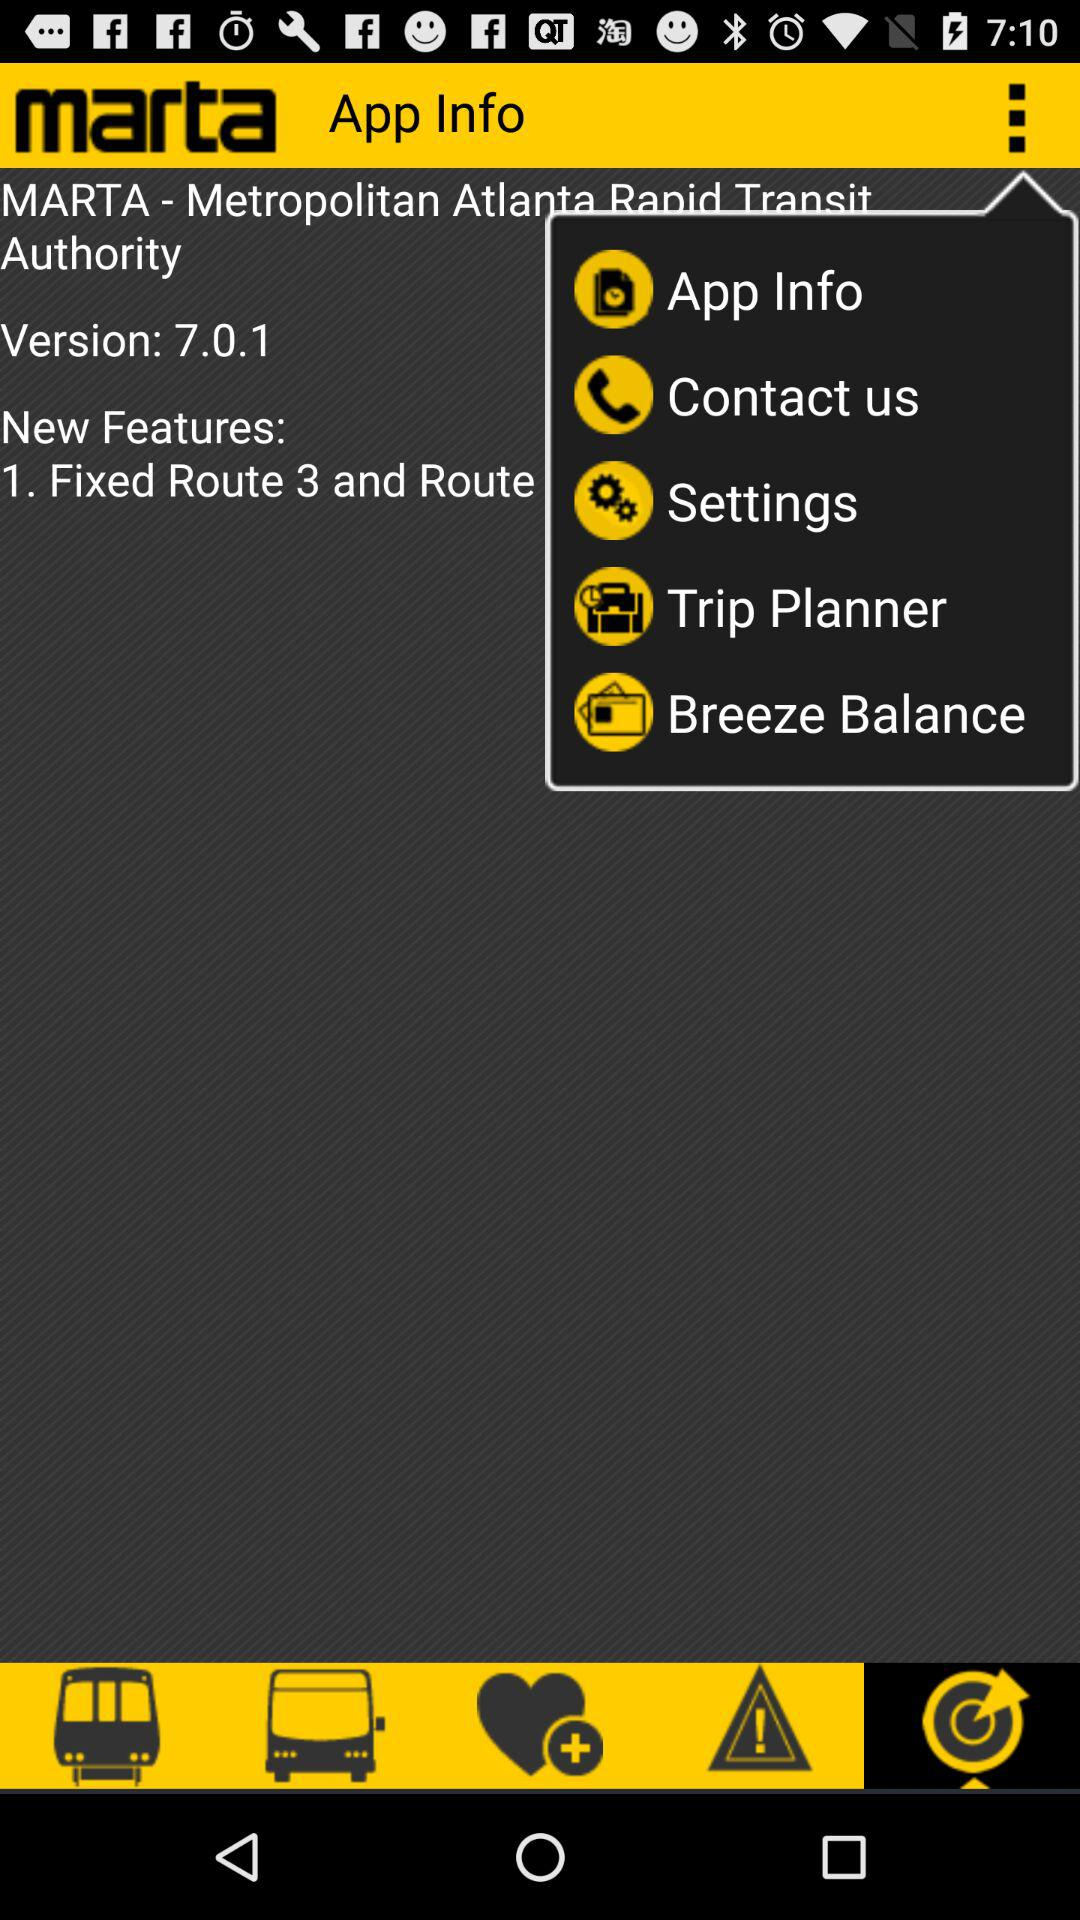What is the version? The version is 7.0.1. 